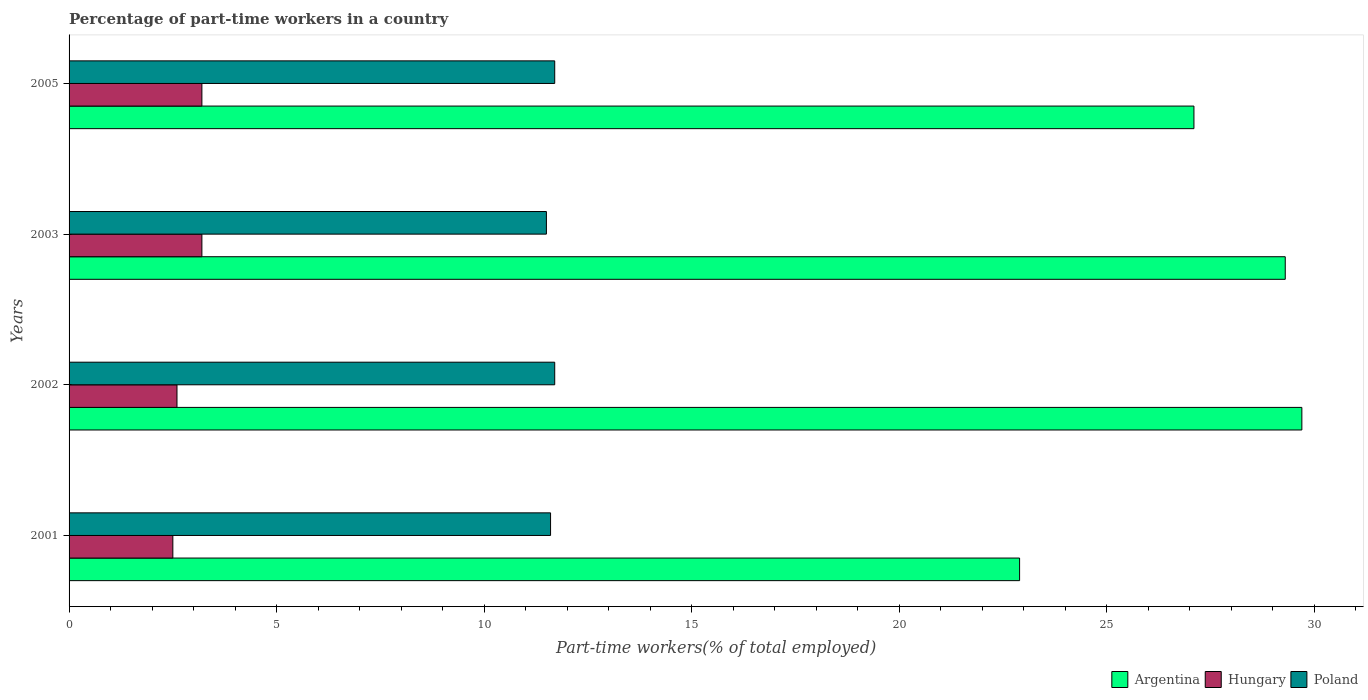How many different coloured bars are there?
Ensure brevity in your answer.  3. Are the number of bars per tick equal to the number of legend labels?
Keep it short and to the point. Yes. Are the number of bars on each tick of the Y-axis equal?
Provide a short and direct response. Yes. How many bars are there on the 1st tick from the top?
Provide a short and direct response. 3. How many bars are there on the 2nd tick from the bottom?
Give a very brief answer. 3. What is the percentage of part-time workers in Hungary in 2002?
Your answer should be very brief. 2.6. Across all years, what is the maximum percentage of part-time workers in Argentina?
Offer a terse response. 29.7. Across all years, what is the minimum percentage of part-time workers in Hungary?
Your answer should be very brief. 2.5. What is the total percentage of part-time workers in Poland in the graph?
Ensure brevity in your answer.  46.5. What is the difference between the percentage of part-time workers in Hungary in 2003 and that in 2005?
Give a very brief answer. 0. What is the difference between the percentage of part-time workers in Hungary in 2005 and the percentage of part-time workers in Argentina in 2003?
Provide a succinct answer. -26.1. What is the average percentage of part-time workers in Poland per year?
Make the answer very short. 11.62. In the year 2001, what is the difference between the percentage of part-time workers in Poland and percentage of part-time workers in Hungary?
Give a very brief answer. 9.1. In how many years, is the percentage of part-time workers in Argentina greater than 18 %?
Ensure brevity in your answer.  4. What is the ratio of the percentage of part-time workers in Hungary in 2002 to that in 2005?
Offer a very short reply. 0.81. Is the difference between the percentage of part-time workers in Poland in 2002 and 2003 greater than the difference between the percentage of part-time workers in Hungary in 2002 and 2003?
Your answer should be very brief. Yes. What is the difference between the highest and the second highest percentage of part-time workers in Argentina?
Provide a succinct answer. 0.4. What is the difference between the highest and the lowest percentage of part-time workers in Hungary?
Offer a terse response. 0.7. Is the sum of the percentage of part-time workers in Poland in 2001 and 2003 greater than the maximum percentage of part-time workers in Hungary across all years?
Your answer should be compact. Yes. How many years are there in the graph?
Provide a short and direct response. 4. Are the values on the major ticks of X-axis written in scientific E-notation?
Give a very brief answer. No. Where does the legend appear in the graph?
Your answer should be compact. Bottom right. How many legend labels are there?
Your answer should be very brief. 3. How are the legend labels stacked?
Provide a succinct answer. Horizontal. What is the title of the graph?
Ensure brevity in your answer.  Percentage of part-time workers in a country. What is the label or title of the X-axis?
Your answer should be very brief. Part-time workers(% of total employed). What is the Part-time workers(% of total employed) in Argentina in 2001?
Keep it short and to the point. 22.9. What is the Part-time workers(% of total employed) in Poland in 2001?
Your answer should be compact. 11.6. What is the Part-time workers(% of total employed) of Argentina in 2002?
Ensure brevity in your answer.  29.7. What is the Part-time workers(% of total employed) of Hungary in 2002?
Your answer should be compact. 2.6. What is the Part-time workers(% of total employed) of Poland in 2002?
Your answer should be very brief. 11.7. What is the Part-time workers(% of total employed) in Argentina in 2003?
Offer a very short reply. 29.3. What is the Part-time workers(% of total employed) in Hungary in 2003?
Keep it short and to the point. 3.2. What is the Part-time workers(% of total employed) of Argentina in 2005?
Provide a short and direct response. 27.1. What is the Part-time workers(% of total employed) in Hungary in 2005?
Give a very brief answer. 3.2. What is the Part-time workers(% of total employed) of Poland in 2005?
Your response must be concise. 11.7. Across all years, what is the maximum Part-time workers(% of total employed) of Argentina?
Your answer should be compact. 29.7. Across all years, what is the maximum Part-time workers(% of total employed) of Hungary?
Make the answer very short. 3.2. Across all years, what is the maximum Part-time workers(% of total employed) of Poland?
Ensure brevity in your answer.  11.7. Across all years, what is the minimum Part-time workers(% of total employed) of Argentina?
Make the answer very short. 22.9. Across all years, what is the minimum Part-time workers(% of total employed) in Hungary?
Provide a succinct answer. 2.5. Across all years, what is the minimum Part-time workers(% of total employed) of Poland?
Your answer should be very brief. 11.5. What is the total Part-time workers(% of total employed) of Argentina in the graph?
Provide a short and direct response. 109. What is the total Part-time workers(% of total employed) in Hungary in the graph?
Your answer should be very brief. 11.5. What is the total Part-time workers(% of total employed) of Poland in the graph?
Provide a short and direct response. 46.5. What is the difference between the Part-time workers(% of total employed) in Argentina in 2001 and that in 2002?
Offer a terse response. -6.8. What is the difference between the Part-time workers(% of total employed) of Hungary in 2001 and that in 2002?
Make the answer very short. -0.1. What is the difference between the Part-time workers(% of total employed) in Hungary in 2001 and that in 2003?
Your answer should be compact. -0.7. What is the difference between the Part-time workers(% of total employed) in Poland in 2001 and that in 2003?
Your answer should be very brief. 0.1. What is the difference between the Part-time workers(% of total employed) of Hungary in 2002 and that in 2003?
Keep it short and to the point. -0.6. What is the difference between the Part-time workers(% of total employed) in Argentina in 2002 and that in 2005?
Make the answer very short. 2.6. What is the difference between the Part-time workers(% of total employed) of Poland in 2002 and that in 2005?
Make the answer very short. 0. What is the difference between the Part-time workers(% of total employed) of Argentina in 2001 and the Part-time workers(% of total employed) of Hungary in 2002?
Make the answer very short. 20.3. What is the difference between the Part-time workers(% of total employed) in Hungary in 2001 and the Part-time workers(% of total employed) in Poland in 2002?
Give a very brief answer. -9.2. What is the difference between the Part-time workers(% of total employed) in Argentina in 2001 and the Part-time workers(% of total employed) in Poland in 2003?
Your answer should be compact. 11.4. What is the difference between the Part-time workers(% of total employed) in Argentina in 2001 and the Part-time workers(% of total employed) in Poland in 2005?
Your answer should be compact. 11.2. What is the difference between the Part-time workers(% of total employed) of Argentina in 2002 and the Part-time workers(% of total employed) of Poland in 2003?
Provide a short and direct response. 18.2. What is the difference between the Part-time workers(% of total employed) of Argentina in 2002 and the Part-time workers(% of total employed) of Hungary in 2005?
Your answer should be very brief. 26.5. What is the difference between the Part-time workers(% of total employed) in Hungary in 2002 and the Part-time workers(% of total employed) in Poland in 2005?
Your answer should be very brief. -9.1. What is the difference between the Part-time workers(% of total employed) in Argentina in 2003 and the Part-time workers(% of total employed) in Hungary in 2005?
Give a very brief answer. 26.1. What is the difference between the Part-time workers(% of total employed) of Argentina in 2003 and the Part-time workers(% of total employed) of Poland in 2005?
Your response must be concise. 17.6. What is the difference between the Part-time workers(% of total employed) of Hungary in 2003 and the Part-time workers(% of total employed) of Poland in 2005?
Your answer should be very brief. -8.5. What is the average Part-time workers(% of total employed) of Argentina per year?
Make the answer very short. 27.25. What is the average Part-time workers(% of total employed) of Hungary per year?
Provide a succinct answer. 2.88. What is the average Part-time workers(% of total employed) of Poland per year?
Provide a short and direct response. 11.62. In the year 2001, what is the difference between the Part-time workers(% of total employed) in Argentina and Part-time workers(% of total employed) in Hungary?
Your answer should be very brief. 20.4. In the year 2001, what is the difference between the Part-time workers(% of total employed) of Argentina and Part-time workers(% of total employed) of Poland?
Offer a very short reply. 11.3. In the year 2002, what is the difference between the Part-time workers(% of total employed) in Argentina and Part-time workers(% of total employed) in Hungary?
Provide a short and direct response. 27.1. In the year 2002, what is the difference between the Part-time workers(% of total employed) of Argentina and Part-time workers(% of total employed) of Poland?
Your response must be concise. 18. In the year 2003, what is the difference between the Part-time workers(% of total employed) in Argentina and Part-time workers(% of total employed) in Hungary?
Offer a very short reply. 26.1. In the year 2003, what is the difference between the Part-time workers(% of total employed) of Argentina and Part-time workers(% of total employed) of Poland?
Offer a terse response. 17.8. In the year 2003, what is the difference between the Part-time workers(% of total employed) of Hungary and Part-time workers(% of total employed) of Poland?
Your response must be concise. -8.3. In the year 2005, what is the difference between the Part-time workers(% of total employed) of Argentina and Part-time workers(% of total employed) of Hungary?
Offer a terse response. 23.9. What is the ratio of the Part-time workers(% of total employed) of Argentina in 2001 to that in 2002?
Offer a very short reply. 0.77. What is the ratio of the Part-time workers(% of total employed) in Hungary in 2001 to that in 2002?
Offer a very short reply. 0.96. What is the ratio of the Part-time workers(% of total employed) in Argentina in 2001 to that in 2003?
Your answer should be compact. 0.78. What is the ratio of the Part-time workers(% of total employed) in Hungary in 2001 to that in 2003?
Your answer should be very brief. 0.78. What is the ratio of the Part-time workers(% of total employed) of Poland in 2001 to that in 2003?
Make the answer very short. 1.01. What is the ratio of the Part-time workers(% of total employed) of Argentina in 2001 to that in 2005?
Keep it short and to the point. 0.84. What is the ratio of the Part-time workers(% of total employed) in Hungary in 2001 to that in 2005?
Offer a very short reply. 0.78. What is the ratio of the Part-time workers(% of total employed) of Argentina in 2002 to that in 2003?
Offer a terse response. 1.01. What is the ratio of the Part-time workers(% of total employed) in Hungary in 2002 to that in 2003?
Your response must be concise. 0.81. What is the ratio of the Part-time workers(% of total employed) in Poland in 2002 to that in 2003?
Make the answer very short. 1.02. What is the ratio of the Part-time workers(% of total employed) of Argentina in 2002 to that in 2005?
Your answer should be very brief. 1.1. What is the ratio of the Part-time workers(% of total employed) in Hungary in 2002 to that in 2005?
Offer a very short reply. 0.81. What is the ratio of the Part-time workers(% of total employed) in Poland in 2002 to that in 2005?
Your response must be concise. 1. What is the ratio of the Part-time workers(% of total employed) of Argentina in 2003 to that in 2005?
Offer a very short reply. 1.08. What is the ratio of the Part-time workers(% of total employed) in Hungary in 2003 to that in 2005?
Keep it short and to the point. 1. What is the ratio of the Part-time workers(% of total employed) of Poland in 2003 to that in 2005?
Keep it short and to the point. 0.98. What is the difference between the highest and the second highest Part-time workers(% of total employed) in Argentina?
Your answer should be very brief. 0.4. What is the difference between the highest and the lowest Part-time workers(% of total employed) in Poland?
Offer a terse response. 0.2. 